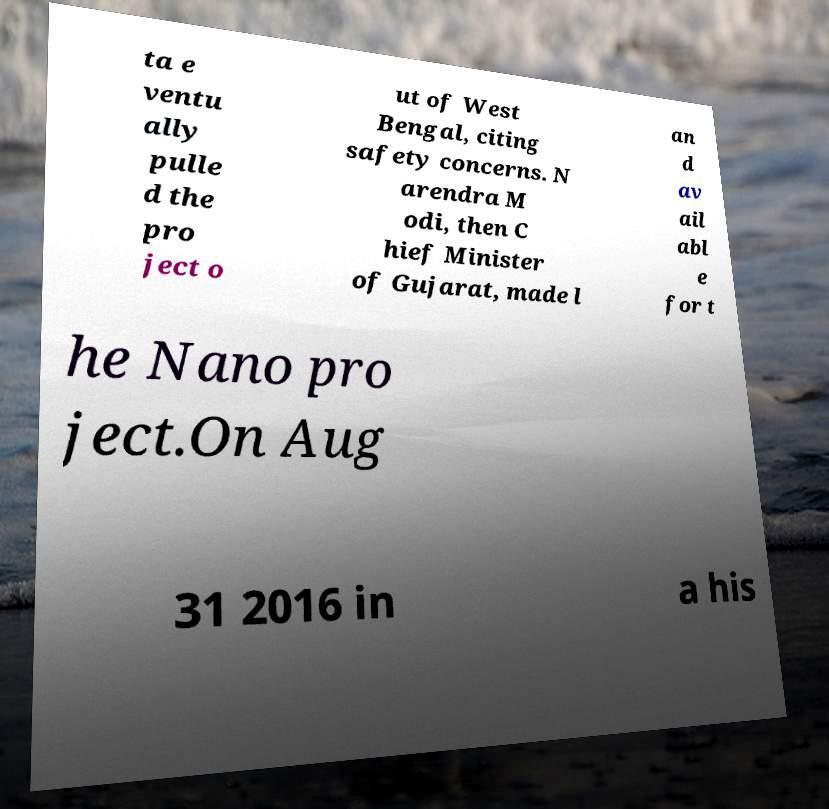There's text embedded in this image that I need extracted. Can you transcribe it verbatim? ta e ventu ally pulle d the pro ject o ut of West Bengal, citing safety concerns. N arendra M odi, then C hief Minister of Gujarat, made l an d av ail abl e for t he Nano pro ject.On Aug 31 2016 in a his 